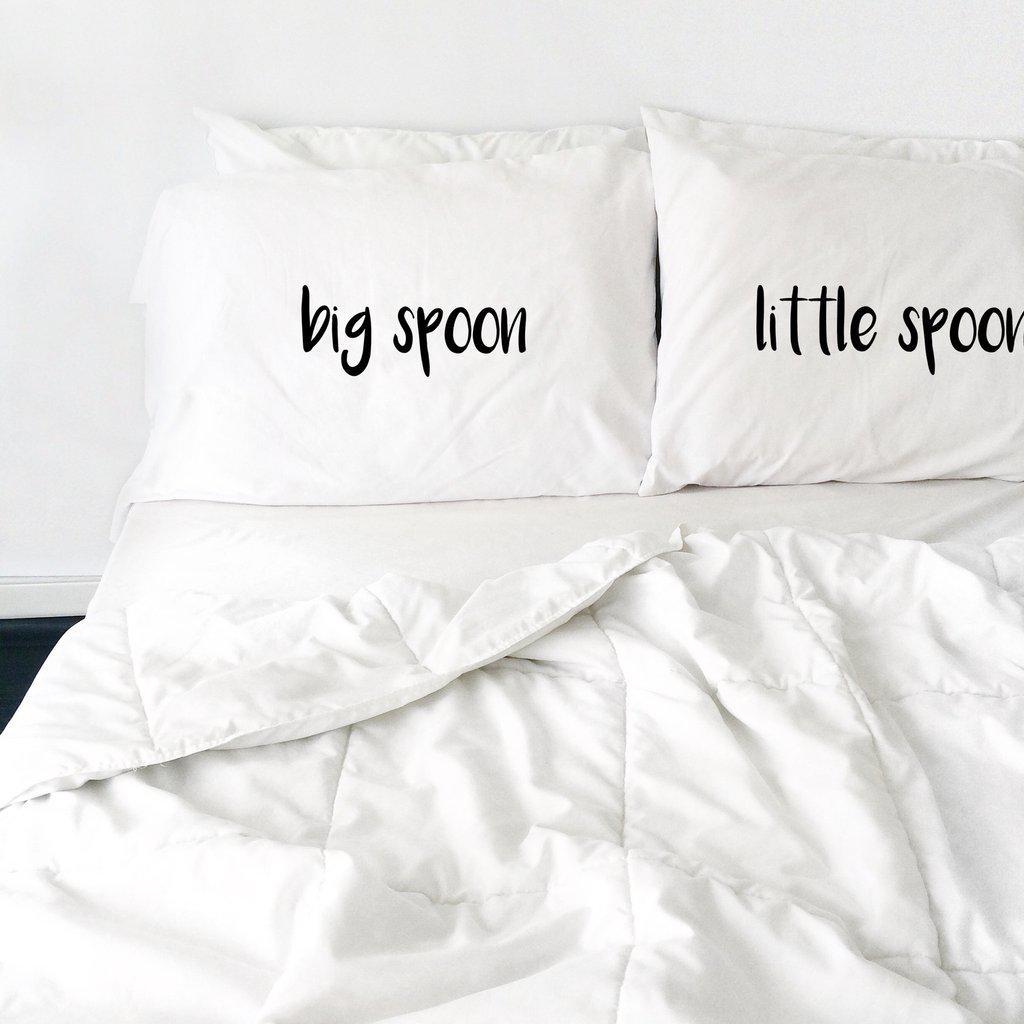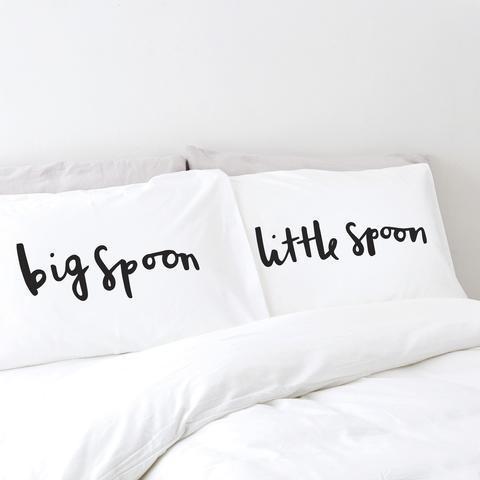The first image is the image on the left, the second image is the image on the right. For the images displayed, is the sentence "Each image shows a set of white pillows angled upward at the head of a bed, each set with the same saying but a different letter design." factually correct? Answer yes or no. Yes. The first image is the image on the left, the second image is the image on the right. For the images displayed, is the sentence "A pair of pillows are side-by-side on a bed and printed with spoon shapes below lettering." factually correct? Answer yes or no. No. 